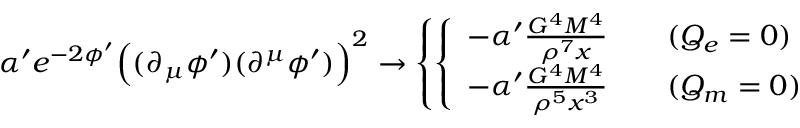<formula> <loc_0><loc_0><loc_500><loc_500>\alpha ^ { \prime } e ^ { - 2 \phi ^ { \prime } } \left ( ( \partial _ { \mu } \phi ^ { \prime } ) ( \partial ^ { \mu } \phi ^ { \prime } ) \right ) ^ { 2 } \rightarrow \left \{ \left \{ \begin{array} { l l } { { - \alpha ^ { \prime } \frac { G ^ { 4 } M ^ { 4 } } { \rho ^ { 7 } x } } } & { { ( Q _ { e } = 0 ) } } \\ { { - \alpha ^ { \prime } \frac { G ^ { 4 } M ^ { 4 } } { \rho ^ { 5 } x ^ { 3 } } } } & { { ( Q _ { m } = 0 ) } } \end{array}</formula> 